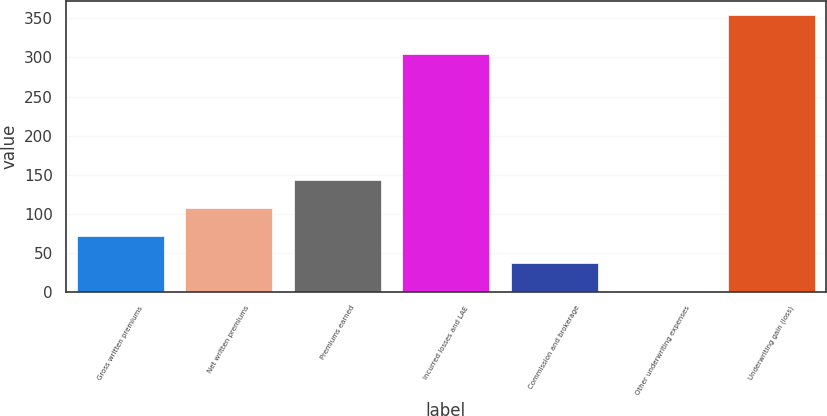<chart> <loc_0><loc_0><loc_500><loc_500><bar_chart><fcel>Gross written premiums<fcel>Net written premiums<fcel>Premiums earned<fcel>Incurred losses and LAE<fcel>Commission and brokerage<fcel>Other underwriting expenses<fcel>Underwriting gain (loss)<nl><fcel>71.8<fcel>107.2<fcel>142.6<fcel>304.8<fcel>36.4<fcel>1<fcel>355<nl></chart> 